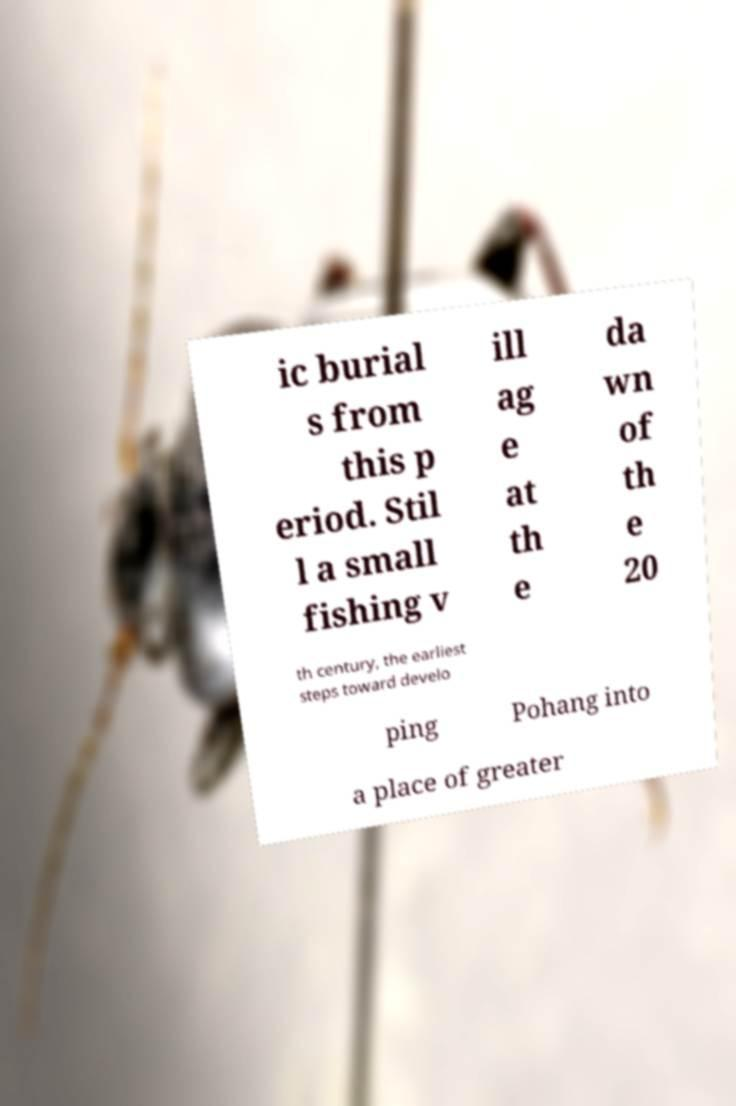For documentation purposes, I need the text within this image transcribed. Could you provide that? ic burial s from this p eriod. Stil l a small fishing v ill ag e at th e da wn of th e 20 th century, the earliest steps toward develo ping Pohang into a place of greater 